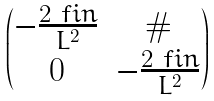Convert formula to latex. <formula><loc_0><loc_0><loc_500><loc_500>\begin{pmatrix} - \frac { 2 \ f i n } { L ^ { 2 } } & \# \\ 0 & - \frac { 2 \ f i n } { L ^ { 2 } } \end{pmatrix}</formula> 